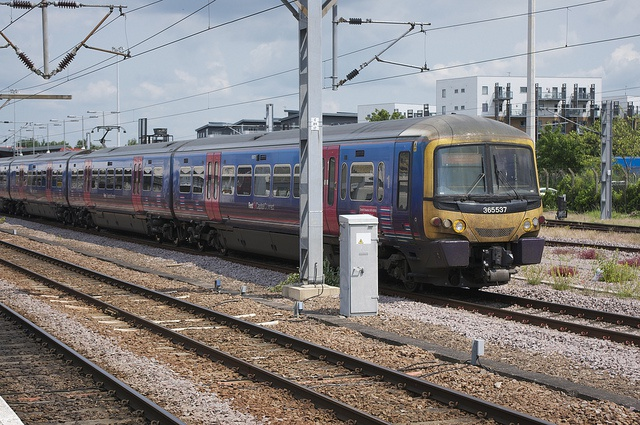Describe the objects in this image and their specific colors. I can see a train in darkgray, black, and gray tones in this image. 